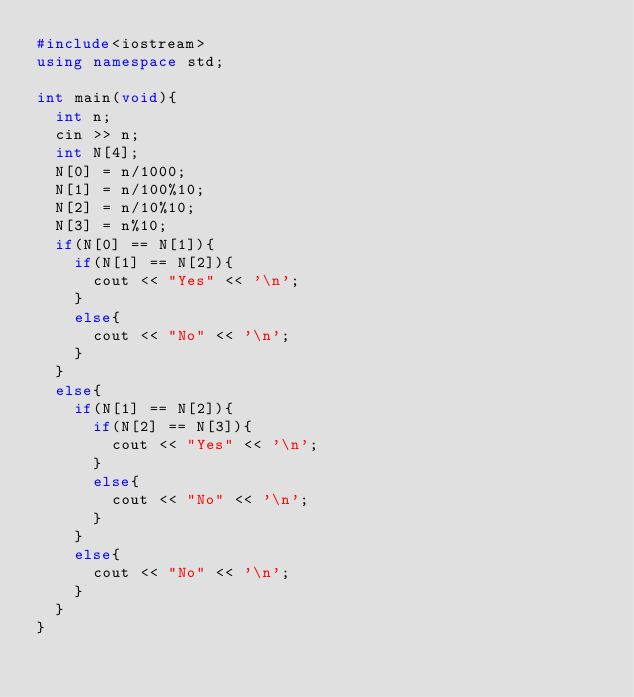Convert code to text. <code><loc_0><loc_0><loc_500><loc_500><_C++_>#include<iostream>
using namespace std;

int main(void){
  int n;
  cin >> n;
  int N[4];
  N[0] = n/1000;
  N[1] = n/100%10;
  N[2] = n/10%10;
  N[3] = n%10;
  if(N[0] == N[1]){
    if(N[1] == N[2]){
      cout << "Yes" << '\n';
    }
    else{
      cout << "No" << '\n';
    }
  }
  else{
    if(N[1] == N[2]){
      if(N[2] == N[3]){
        cout << "Yes" << '\n';
      }
      else{
        cout << "No" << '\n';
      }
    }
    else{
      cout << "No" << '\n';
    }
  }
}
</code> 